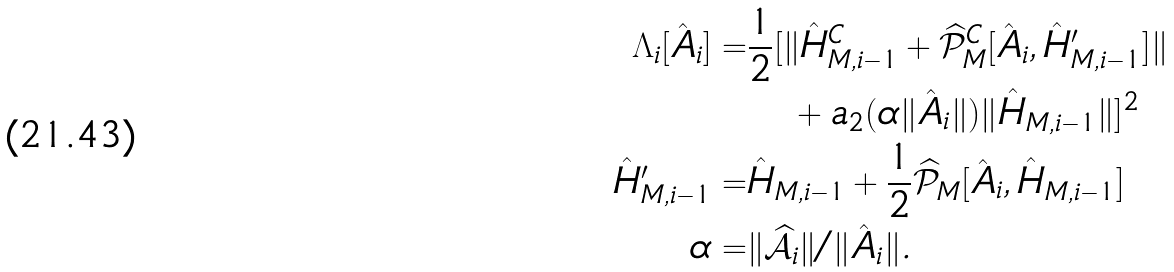<formula> <loc_0><loc_0><loc_500><loc_500>\Lambda _ { i } [ \hat { A } _ { i } ] = & \frac { 1 } { 2 } [ \| \hat { H } _ { M , i - 1 } ^ { C } + \widehat { \mathcal { P } } _ { M } ^ { C } [ \hat { A } _ { i } , \hat { H } ^ { \prime } _ { M , i - 1 } ] \| \\ & \quad + a _ { 2 } ( \alpha \| \hat { A } _ { i } \| ) \| \hat { H } _ { M , i - 1 } \| ] ^ { 2 } \\ \hat { H } ^ { \prime } _ { M , i - 1 } = & \hat { H } _ { M , i - 1 } + \frac { 1 } { 2 } \widehat { \mathcal { P } } _ { M } [ \hat { A } _ { i } , \hat { H } _ { M , i - 1 } ] \\ \alpha = & \| \widehat { \mathcal { A } } _ { i } \| / \| \hat { A } _ { i } \| .</formula> 